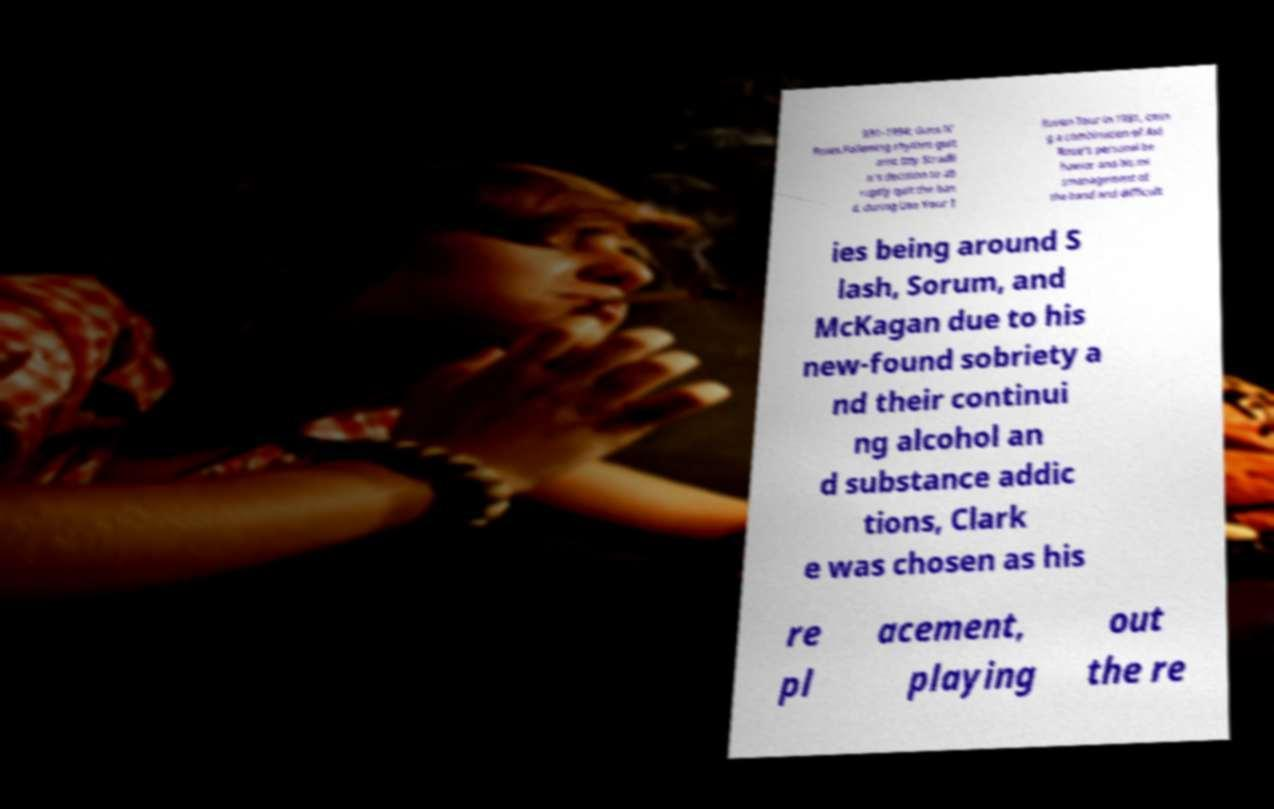Please read and relay the text visible in this image. What does it say? 991–1994: Guns N' Roses.Following rhythm guit arist Izzy Stradli n's decision to ab ruptly quit the ban d, during Use Your I llusion Tour in 1991, citin g a combination of Axl Rose's personal be havior and his mi smanagement of the band and difficult ies being around S lash, Sorum, and McKagan due to his new-found sobriety a nd their continui ng alcohol an d substance addic tions, Clark e was chosen as his re pl acement, playing out the re 